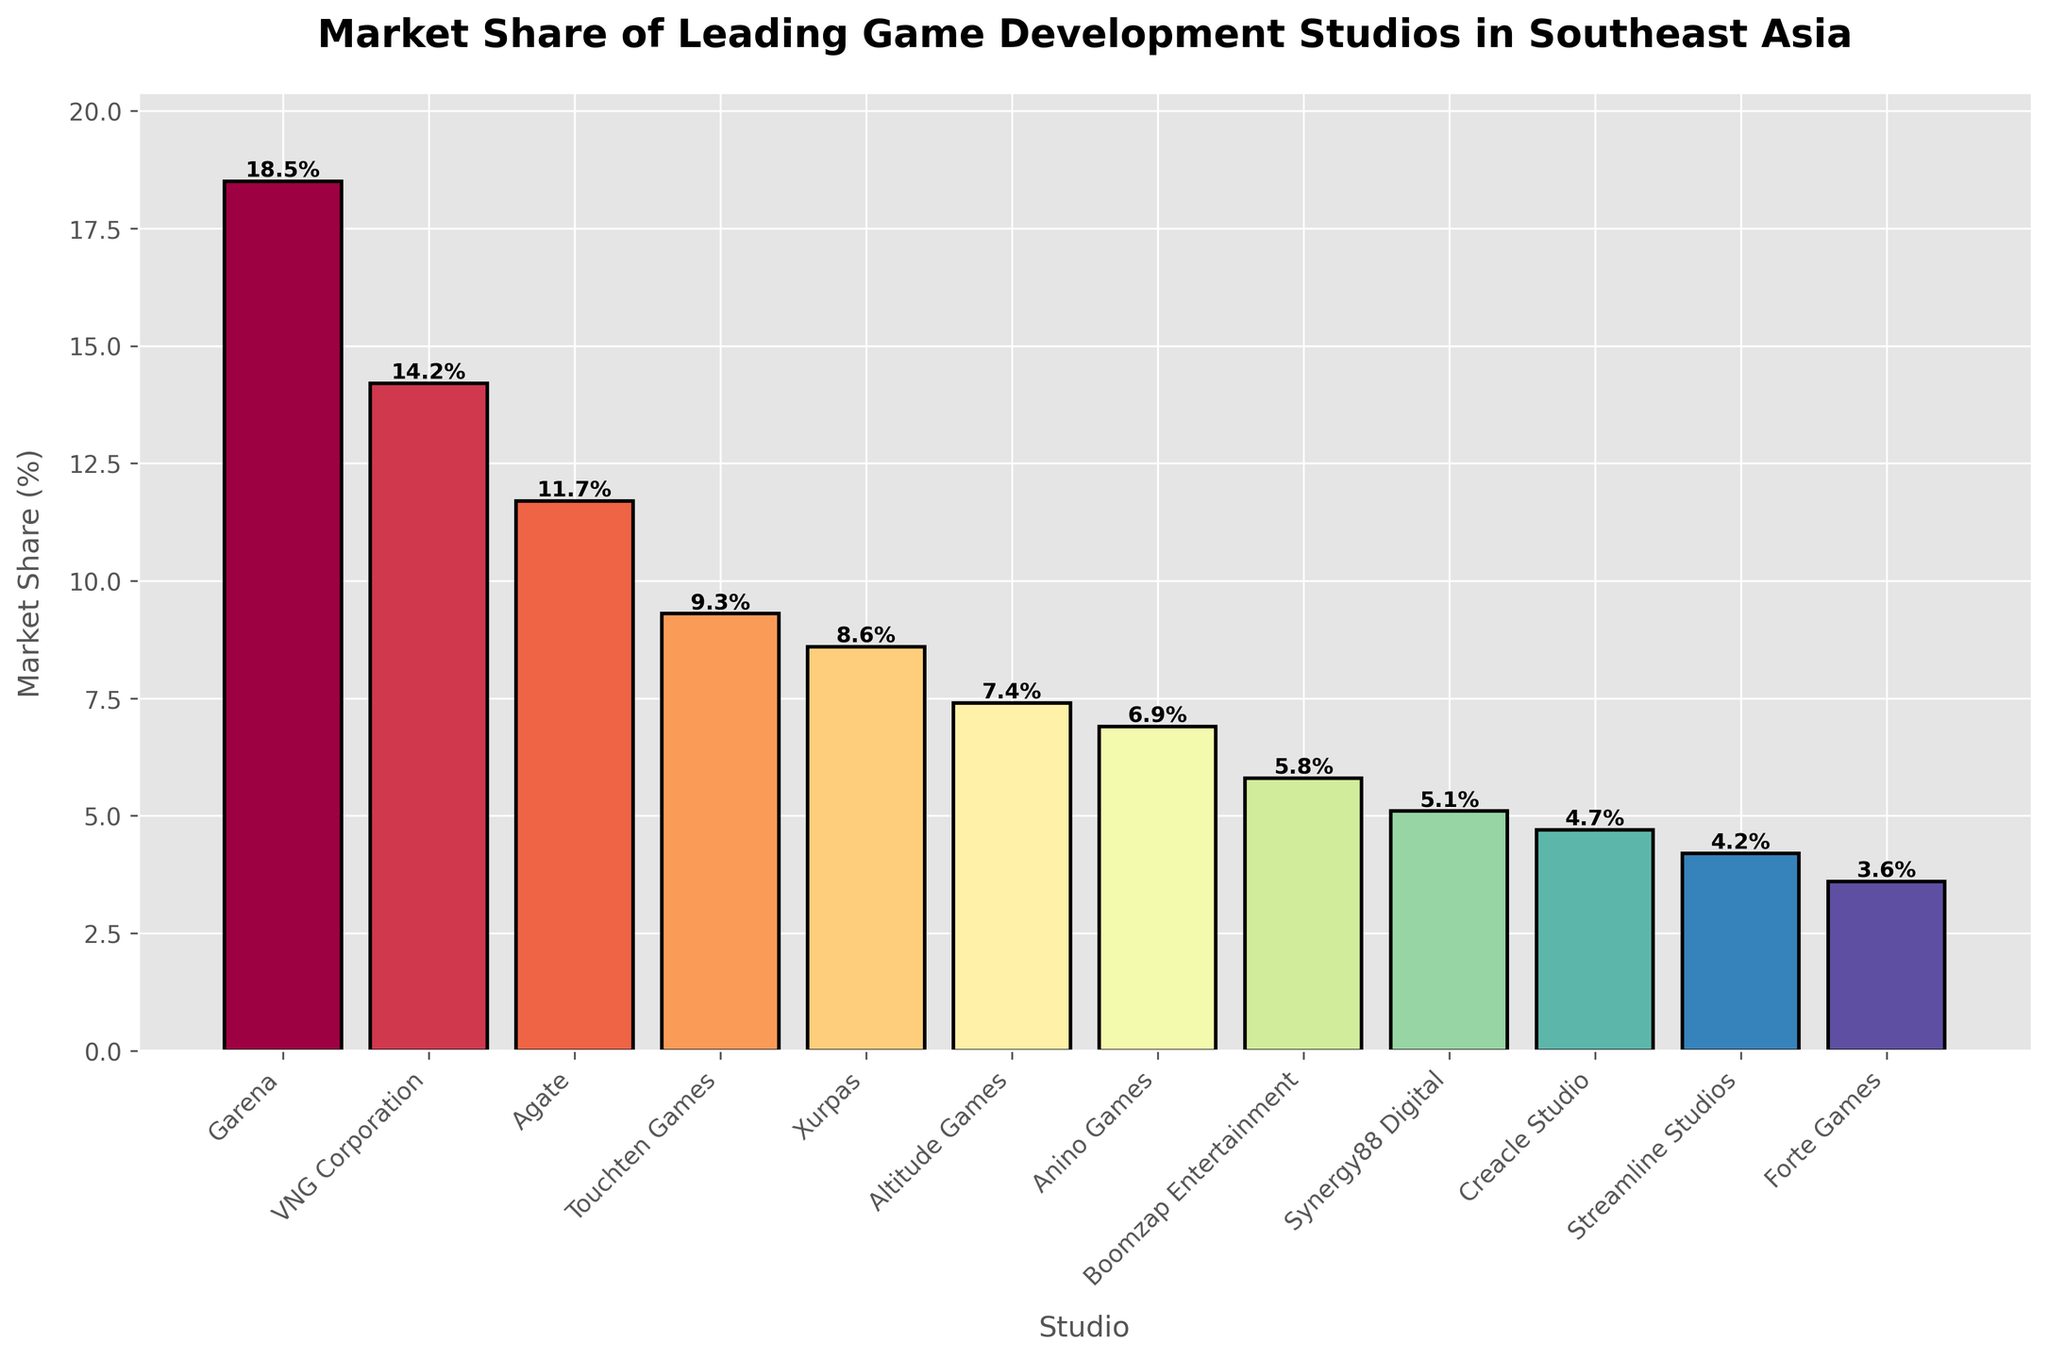What's the market share of the leading studio? The leading studio is Garena, as its bar is the tallest. Garena's market share is indicated at the top of the bar, which is 18.5%.
Answer: 18.5% Which studio has the lowest market share, and what is it? The studio with the shortest bar has the lowest market share. Creacle Studio's bar is the shortest, with a market share of 3.6%.
Answer: Creacle Studio, 3.6% What is the total market share of studios with more than 10% share? Studios with more than 10% market share are Garena (18.5%), VNG Corporation (14.2%), and Agate (11.7%). Summing these values gives 18.5 + 14.2 + 11.7 = 44.4%.
Answer: 44.4% How does the market share of Touchten Games compare to Xurpas? Touchten Games has a market share of 9.3%, which is higher than Xurpas, which has 8.6%. By comparing the height of the bars, one can see Touchten Games' bar is taller.
Answer: Touchten Games has a higher market share Which studio is closest in market share to Anino Games? Studio bars are visually inspected to find the closest in height to Anino Games' bar. Boomzap Entertainment, with a market share of 5.8%, is closest to Anino Games' market share of 6.9%.
Answer: Boomzap Entertainment Are there any studios with exactly the same market share? By comparing the height and the values of each bar, no two studios have exactly the same market share, as each bar has a unique height and value.
Answer: No How many studios have a market share between 5% and 10%? Studios with market shares between 5% and 10% are Touchten Games (9.3%), Xurpas (8.6%), Altitude Games (7.4%), Anino Games (6.9%), and Synergy88 Digital (5.1%). Counting these studios gives 5.
Answer: 5 What is the combined market share of the two smallest studios? The smallest studios are Creacle Studio (3.6%) and Forte Games (4.2%). Summing these values gives 3.6 + 4.2 = 7.8%.
Answer: 7.8% What's the mean market share of all studios? To find the mean, sum all market shares and divide by the number of studios. The sum is 18.5 + 14.2 + 11.7 + 9.3 + 8.6 + 7.4 + 6.9 + 5.8 + 5.1 + 4.7 + 4.2 + 3.6 = 100.
Answer: 100 / 12 = 8.33% Which studio's share is closest to the average market share? The average market share is 8.33%. The studio closest to this value is Xurpas, with a market share of 8.6%.
Answer: Xurpas 